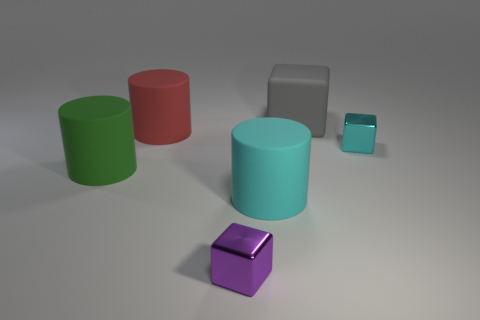Add 3 large gray things. How many objects exist? 9 Subtract all cyan cubes. How many cubes are left? 2 Subtract all gray blocks. How many blocks are left? 2 Subtract 0 blue cylinders. How many objects are left? 6 Subtract 2 cylinders. How many cylinders are left? 1 Subtract all purple cylinders. Subtract all yellow spheres. How many cylinders are left? 3 Subtract all cyan cylinders. How many cyan blocks are left? 1 Subtract all large green rubber things. Subtract all large cyan rubber balls. How many objects are left? 5 Add 5 large gray rubber blocks. How many large gray rubber blocks are left? 6 Add 5 purple blocks. How many purple blocks exist? 6 